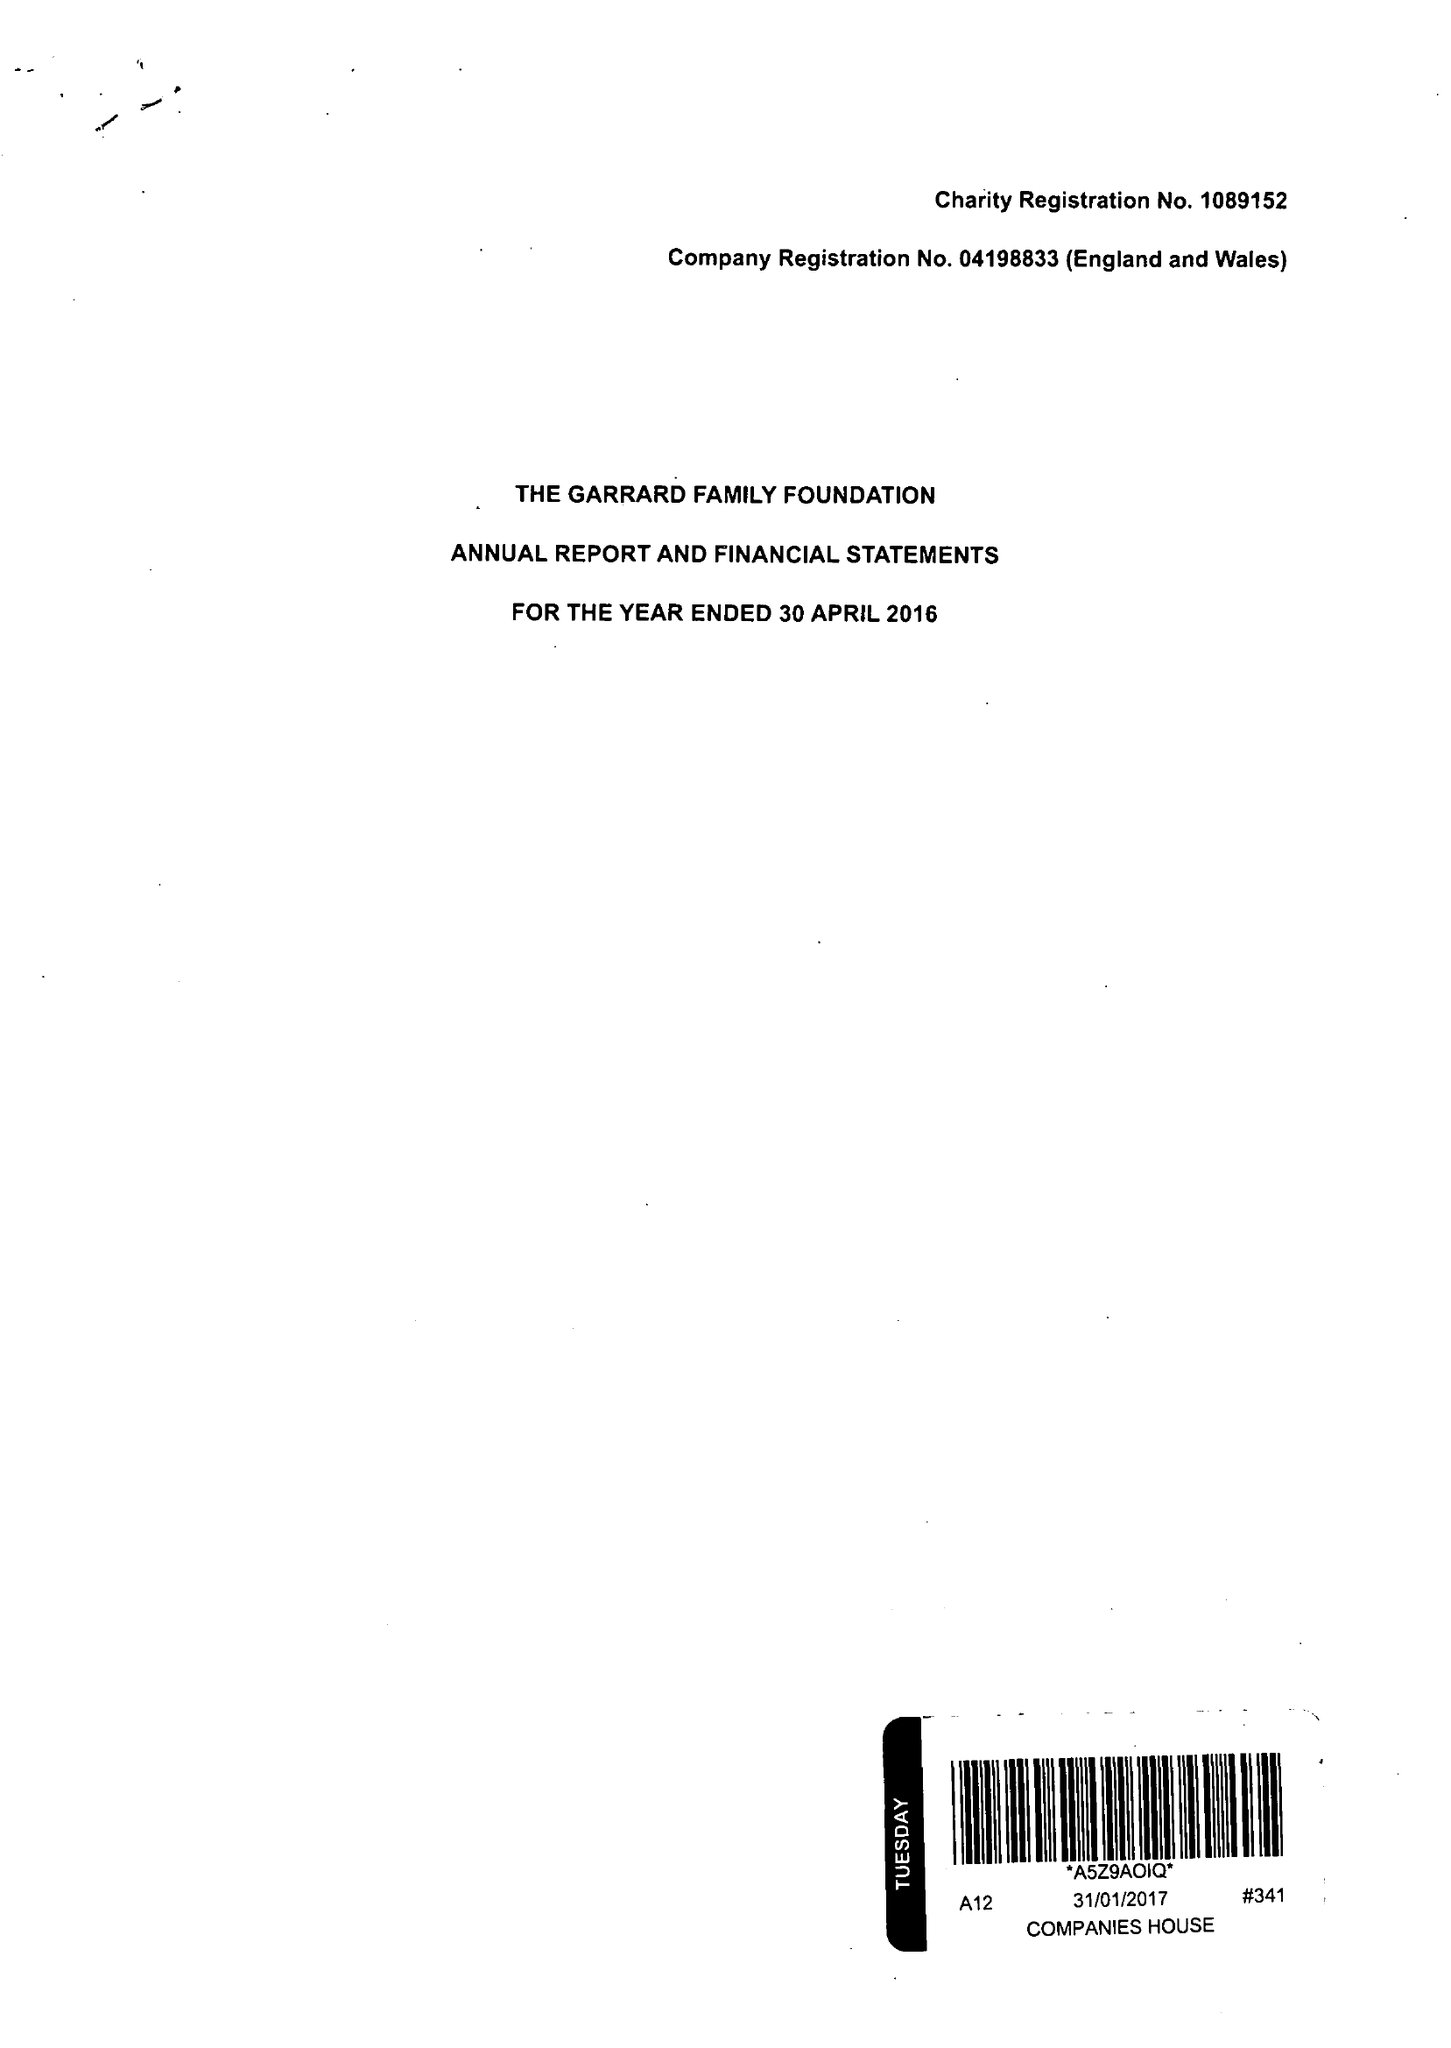What is the value for the address__street_line?
Answer the question using a single word or phrase. 73 CORNHILL 